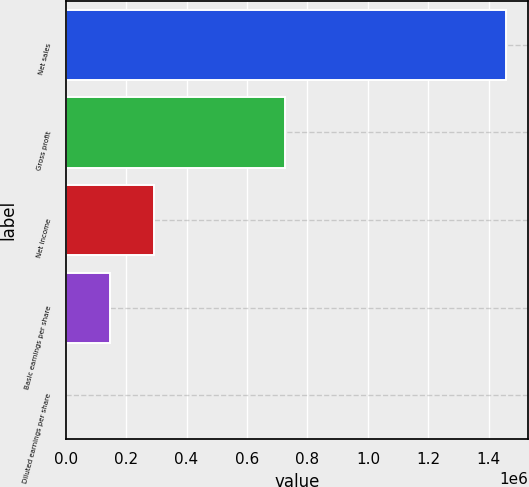Convert chart to OTSL. <chart><loc_0><loc_0><loc_500><loc_500><bar_chart><fcel>Net sales<fcel>Gross profit<fcel>Net income<fcel>Basic earnings per share<fcel>Diluted earnings per share<nl><fcel>1.45753e+06<fcel>725350<fcel>291506<fcel>145754<fcel>1.21<nl></chart> 